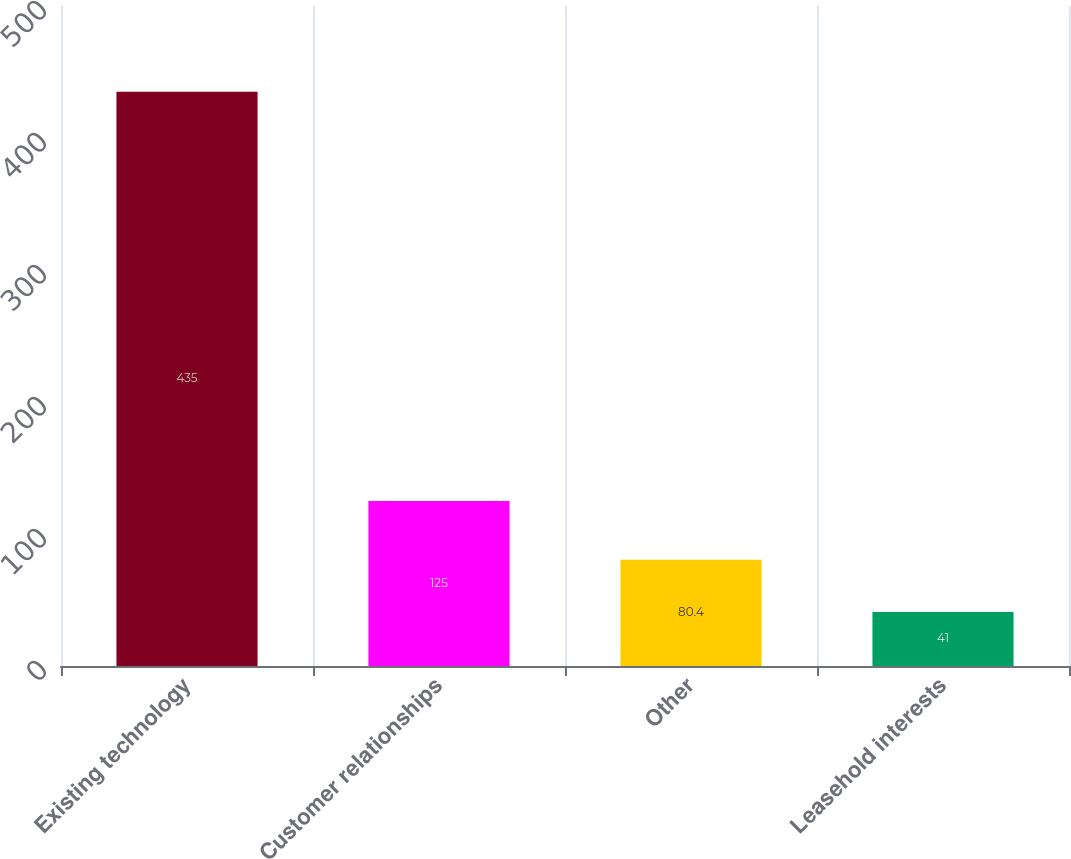<chart> <loc_0><loc_0><loc_500><loc_500><bar_chart><fcel>Existing technology<fcel>Customer relationships<fcel>Other<fcel>Leasehold interests<nl><fcel>435<fcel>125<fcel>80.4<fcel>41<nl></chart> 